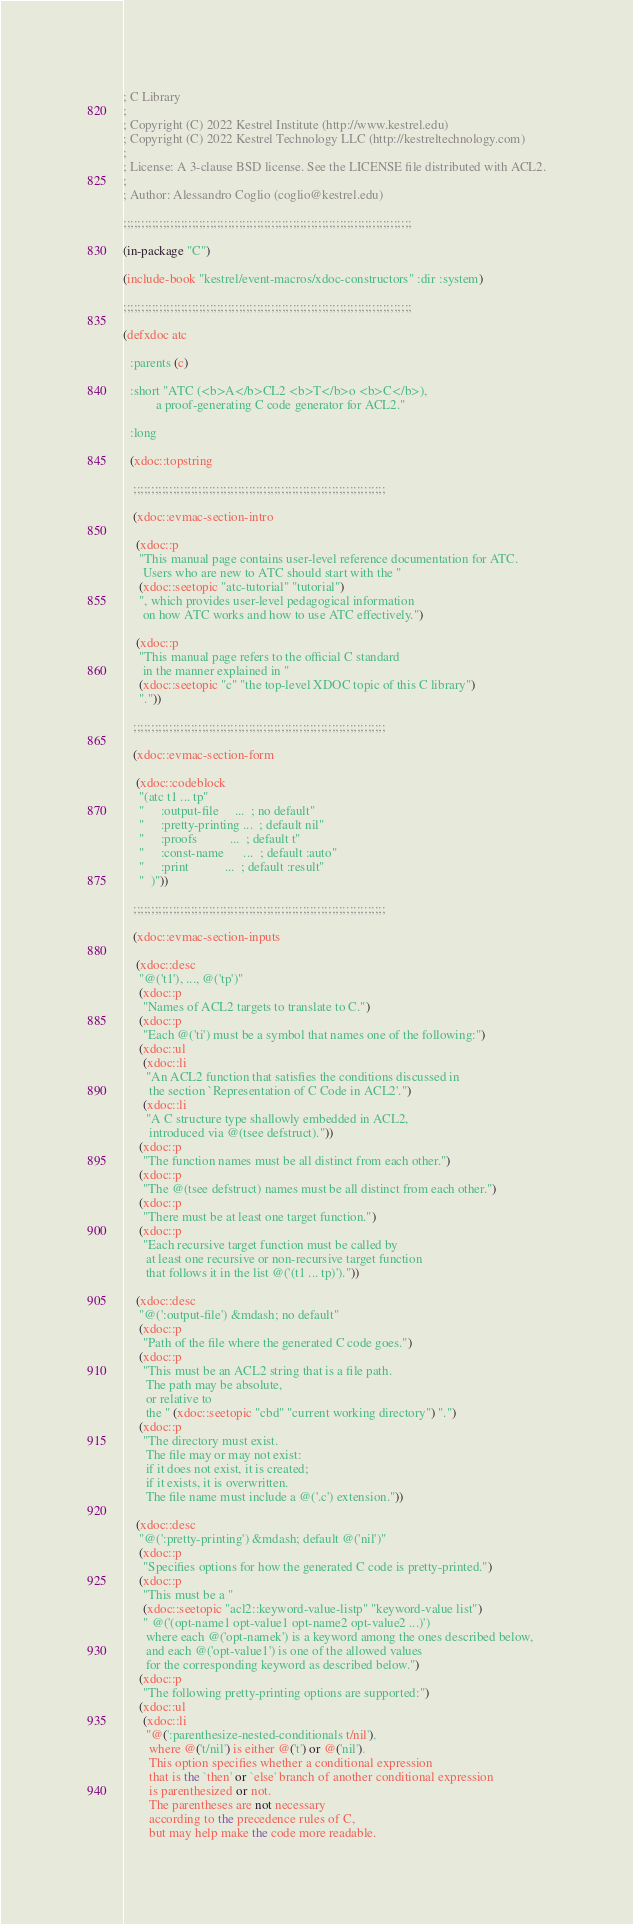Convert code to text. <code><loc_0><loc_0><loc_500><loc_500><_Lisp_>; C Library
;
; Copyright (C) 2022 Kestrel Institute (http://www.kestrel.edu)
; Copyright (C) 2022 Kestrel Technology LLC (http://kestreltechnology.com)
;
; License: A 3-clause BSD license. See the LICENSE file distributed with ACL2.
;
; Author: Alessandro Coglio (coglio@kestrel.edu)

;;;;;;;;;;;;;;;;;;;;;;;;;;;;;;;;;;;;;;;;;;;;;;;;;;;;;;;;;;;;;;;;;;;;;;;;;;;;;;;;

(in-package "C")

(include-book "kestrel/event-macros/xdoc-constructors" :dir :system)

;;;;;;;;;;;;;;;;;;;;;;;;;;;;;;;;;;;;;;;;;;;;;;;;;;;;;;;;;;;;;;;;;;;;;;;;;;;;;;;;

(defxdoc atc

  :parents (c)

  :short "ATC (<b>A</b>CL2 <b>T</b>o <b>C</b>),
          a proof-generating C code generator for ACL2."

  :long

  (xdoc::topstring

   ;;;;;;;;;;;;;;;;;;;;;;;;;;;;;;;;;;;;;;;;;;;;;;;;;;;;;;;;;;;;;;;;;;;;;;

   (xdoc::evmac-section-intro

    (xdoc::p
     "This manual page contains user-level reference documentation for ATC.
      Users who are new to ATC should start with the "
     (xdoc::seetopic "atc-tutorial" "tutorial")
     ", which provides user-level pedagogical information
      on how ATC works and how to use ATC effectively.")

    (xdoc::p
     "This manual page refers to the official C standard
      in the manner explained in "
     (xdoc::seetopic "c" "the top-level XDOC topic of this C library")
     "."))

   ;;;;;;;;;;;;;;;;;;;;;;;;;;;;;;;;;;;;;;;;;;;;;;;;;;;;;;;;;;;;;;;;;;;;;;

   (xdoc::evmac-section-form

    (xdoc::codeblock
     "(atc t1 ... tp"
     "     :output-file     ...  ; no default"
     "     :pretty-printing ...  ; default nil"
     "     :proofs          ...  ; default t"
     "     :const-name      ...  ; default :auto"
     "     :print           ...  ; default :result"
     "  )"))

   ;;;;;;;;;;;;;;;;;;;;;;;;;;;;;;;;;;;;;;;;;;;;;;;;;;;;;;;;;;;;;;;;;;;;;;

   (xdoc::evmac-section-inputs

    (xdoc::desc
     "@('t1'), ..., @('tp')"
     (xdoc::p
      "Names of ACL2 targets to translate to C.")
     (xdoc::p
      "Each @('ti') must be a symbol that names one of the following:")
     (xdoc::ul
      (xdoc::li
       "An ACL2 function that satisfies the conditions discussed in
        the section `Representation of C Code in ACL2'.")
      (xdoc::li
       "A C structure type shallowly embedded in ACL2,
        introduced via @(tsee defstruct)."))
     (xdoc::p
      "The function names must be all distinct from each other.")
     (xdoc::p
      "The @(tsee defstruct) names must be all distinct from each other.")
     (xdoc::p
      "There must be at least one target function.")
     (xdoc::p
      "Each recursive target function must be called by
       at least one recursive or non-recursive target function
       that follows it in the list @('(t1 ... tp)')."))

    (xdoc::desc
     "@(':output-file') &mdash; no default"
     (xdoc::p
      "Path of the file where the generated C code goes.")
     (xdoc::p
      "This must be an ACL2 string that is a file path.
       The path may be absolute,
       or relative to
       the " (xdoc::seetopic "cbd" "current working directory") ".")
     (xdoc::p
      "The directory must exist.
       The file may or may not exist:
       if it does not exist, it is created;
       if it exists, it is overwritten.
       The file name must include a @('.c') extension."))

    (xdoc::desc
     "@(':pretty-printing') &mdash; default @('nil')"
     (xdoc::p
      "Specifies options for how the generated C code is pretty-printed.")
     (xdoc::p
      "This must be a "
      (xdoc::seetopic "acl2::keyword-value-listp" "keyword-value list")
      " @('(opt-name1 opt-value1 opt-name2 opt-value2 ...)')
       where each @('opt-namek') is a keyword among the ones described below,
       and each @('opt-value1') is one of the allowed values
       for the corresponding keyword as described below.")
     (xdoc::p
      "The following pretty-printing options are supported:")
     (xdoc::ul
      (xdoc::li
       "@(':parenthesize-nested-conditionals t/nil'),
        where @('t/nil') is either @('t') or @('nil').
        This option specifies whether a conditional expression
        that is the `then' or `else' branch of another conditional expression
        is parenthesized or not.
        The parentheses are not necessary
        according to the precedence rules of C,
        but may help make the code more readable.</code> 